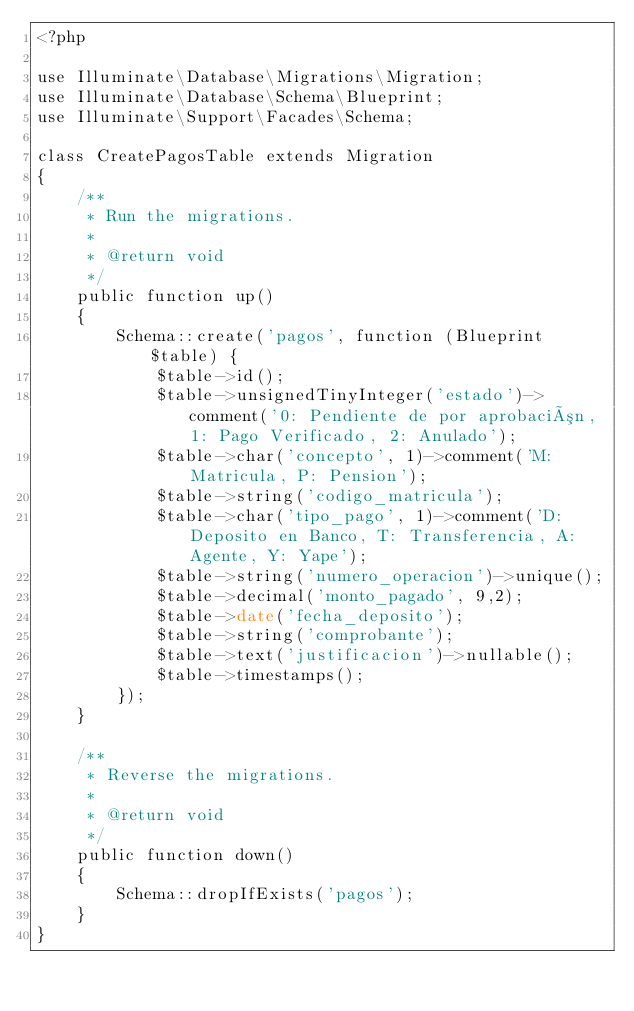Convert code to text. <code><loc_0><loc_0><loc_500><loc_500><_PHP_><?php

use Illuminate\Database\Migrations\Migration;
use Illuminate\Database\Schema\Blueprint;
use Illuminate\Support\Facades\Schema;

class CreatePagosTable extends Migration
{
    /**
     * Run the migrations.
     *
     * @return void
     */
    public function up()
    {
        Schema::create('pagos', function (Blueprint $table) {
            $table->id();
            $table->unsignedTinyInteger('estado')->comment('0: Pendiente de por aprobación, 1: Pago Verificado, 2: Anulado');
            $table->char('concepto', 1)->comment('M: Matricula, P: Pension');
            $table->string('codigo_matricula');
            $table->char('tipo_pago', 1)->comment('D: Deposito en Banco, T: Transferencia, A: Agente, Y: Yape');
            $table->string('numero_operacion')->unique();
            $table->decimal('monto_pagado', 9,2);
            $table->date('fecha_deposito');
            $table->string('comprobante');
            $table->text('justificacion')->nullable();
            $table->timestamps();
        });
    }

    /**
     * Reverse the migrations.
     *
     * @return void
     */
    public function down()
    {
        Schema::dropIfExists('pagos');
    }
}
</code> 